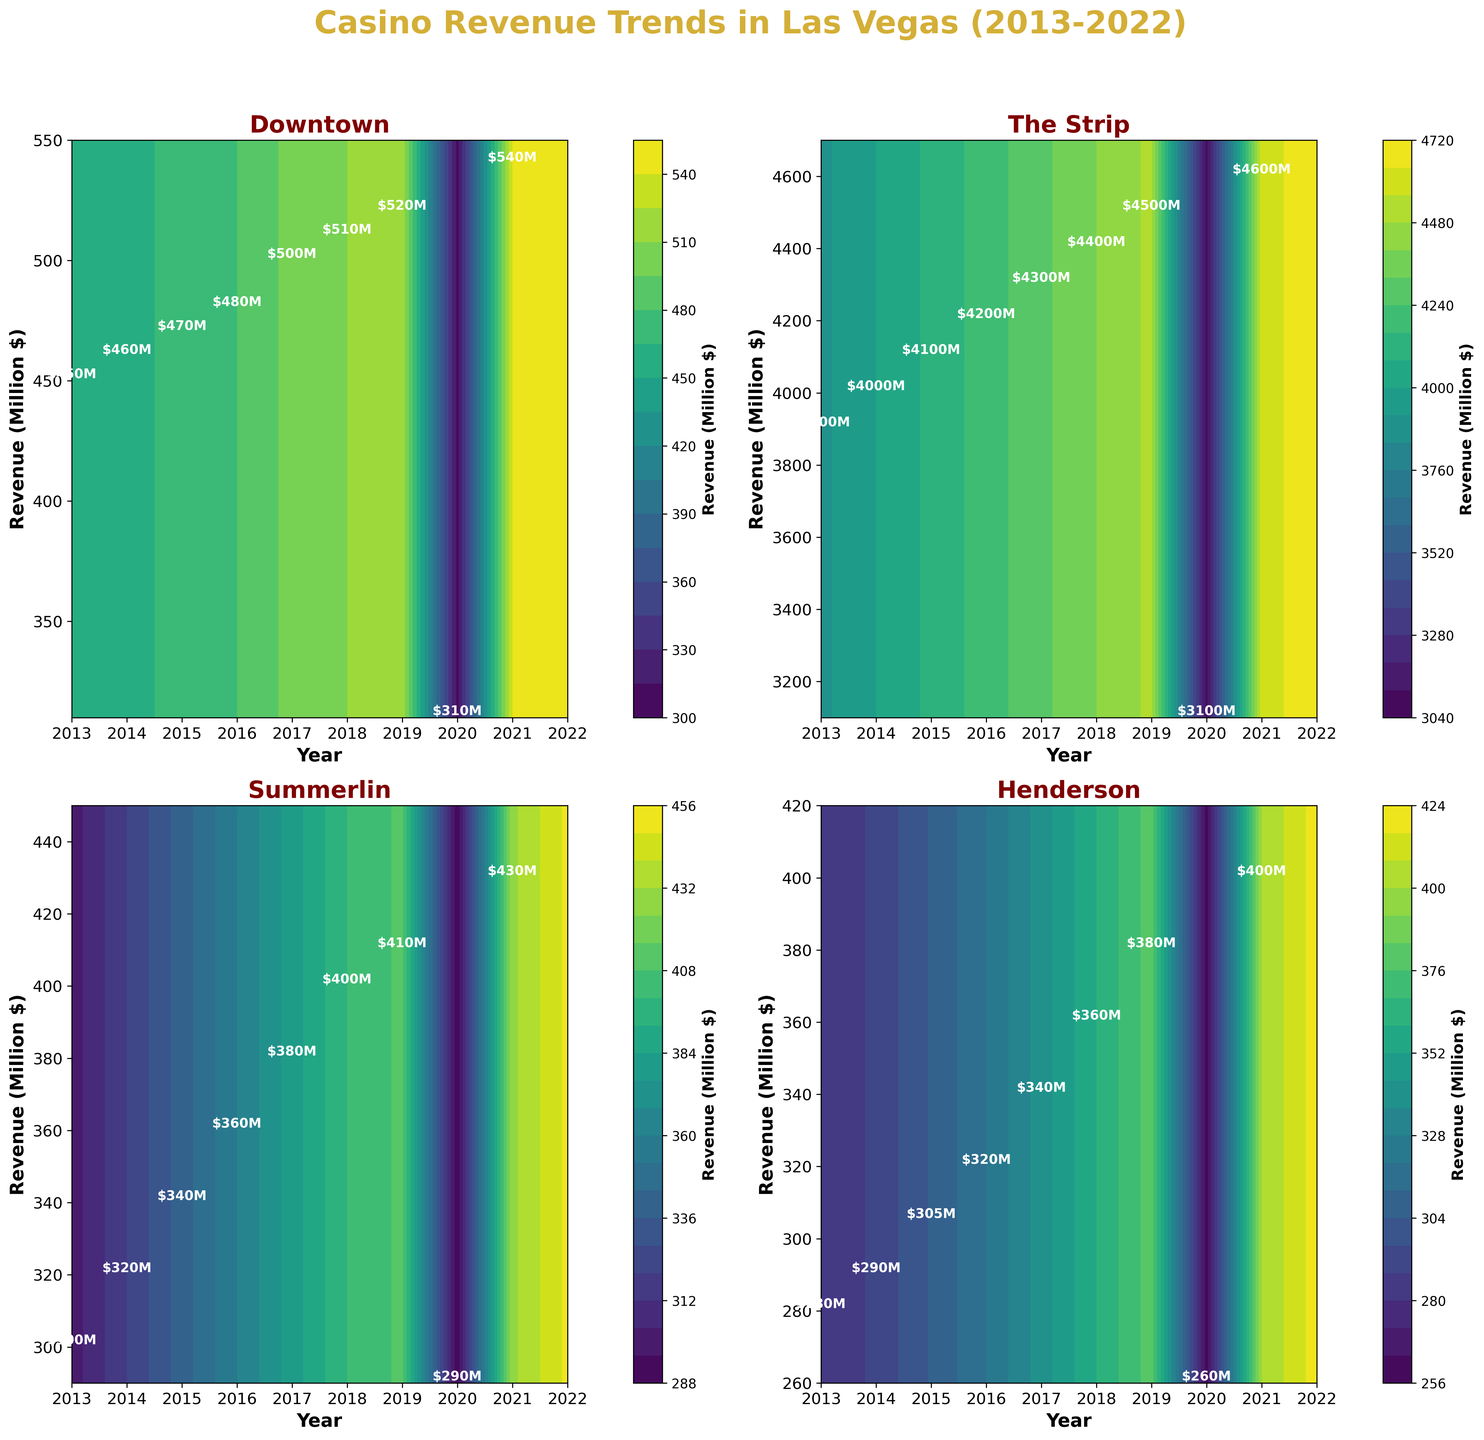Which neighborhood showed the highest revenue in 2022? In the 2022 subplot, The Strip has the highest contour level compared to Downtown, Summerlin, and Henderson. This suggests The Strip had the highest revenue.
Answer: The Strip What is the general trend for casino revenue in Downtown from 2013 to 2022? By examining the contour lines for Downtown from 2013 to 2022, we can see a generally upward trend with a noticeable dip in 2020.
Answer: Upward trend with a dip in 2020 How did the casino revenue in The Strip change from 2019 to 2020? In the subplot for The Strip, the contour levels drop significantly from 2019 to 2020, indicating a drop in revenue.
Answer: Decreased Which neighborhood experienced the largest decrease in revenue in 2020? By comparing the 2020 contours of all neighborhoods, Downtown and The Strip show the most significant drops. Comparing their absolute changes, Downtown dropped from $520M to $310M, which is a larger decrease than The Strip's $4500M to $3100M.
Answer: Downtown Among all neighborhoods, which one had the most consistent increase in revenue from 2013 to 2019? Analyzing each subplot from 2013 to 2019, Summerlin shows a very consistent upward trajectory without significant fluctuations in its contour levels.
Answer: Summerlin What is the revenue difference between Henderson and Summerlin in 2018? Locate the 2018 contours for both neighborhoods. Henderson's contour level reached $360M, while Summerlin’s reached $400M. The difference is $400M - $360M.
Answer: $40M What was the impact of the pandemic year 2020 on the casino revenues in all neighborhoods? In 2020, all neighborhoods show a noticeable drop in revenue in their contour levels compared to 2019.
Answer: Decrease in all neighborhoods How did Summerlin's revenue in 2022 compare to Downtown's revenue in the same year? Check the contour levels for 2022. Summerlin shows around $450M, while Downtown shows around $550M.
Answer: Summerlin’s revenue is lower than Downtown’s If you were to average the revenues of The Strip in the years 2013 and 2022, what would it be? The Strip's revenue in 2013 is $3900M, and in 2022, it's $4700M. The average is calculated as (3900 + 4700) / 2.
Answer: $4300M 